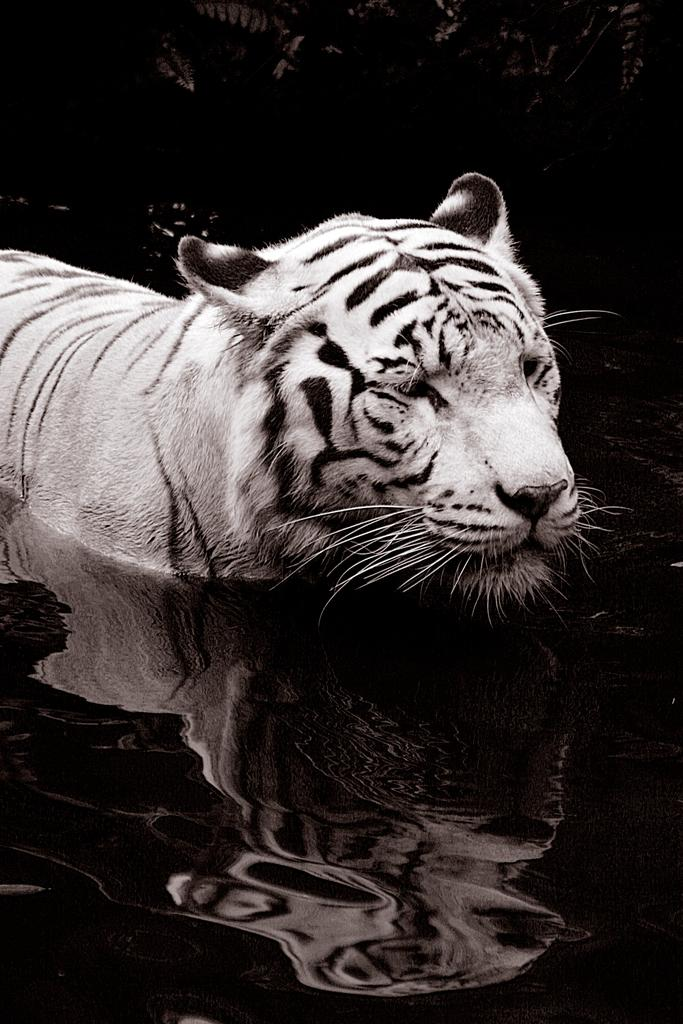What animal is present in the image? There is a tiger in the image. Where is the tiger located? The tiger is in the water. What else can be seen in the image besides the tiger? There are plants visible in the image. What can be inferred about the location of the image? The image appears to be taken in or near the water. What type of stone can be seen in the image? There is no stone present in the image. How many goldfish are swimming with the tiger in the image? There are no goldfish present in the image; it features a tiger in the water. 